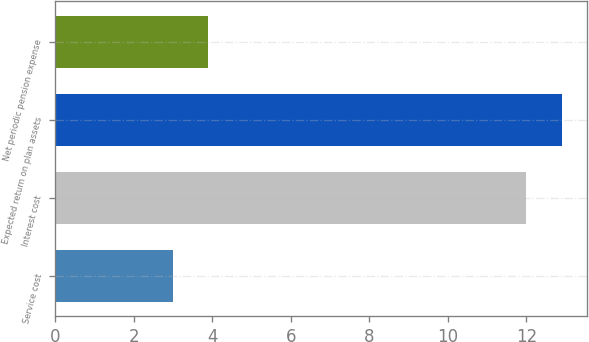<chart> <loc_0><loc_0><loc_500><loc_500><bar_chart><fcel>Service cost<fcel>Interest cost<fcel>Expected return on plan assets<fcel>Net periodic pension expense<nl><fcel>3<fcel>12<fcel>12.9<fcel>3.9<nl></chart> 